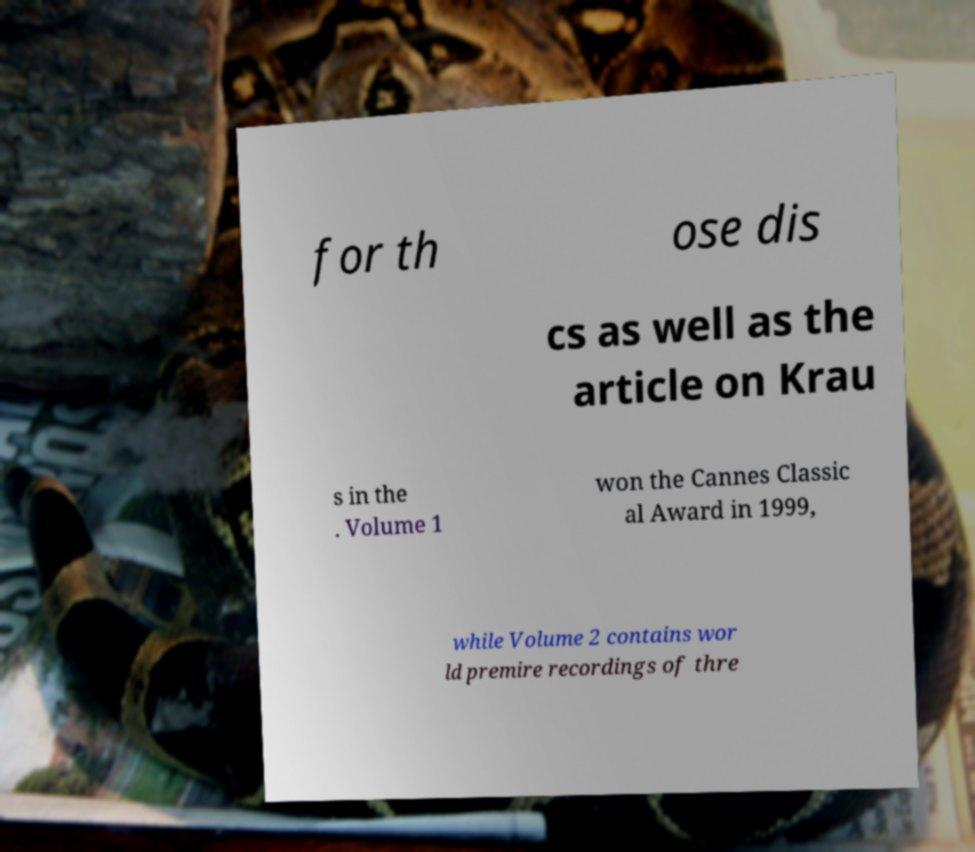Could you extract and type out the text from this image? for th ose dis cs as well as the article on Krau s in the . Volume 1 won the Cannes Classic al Award in 1999, while Volume 2 contains wor ld premire recordings of thre 